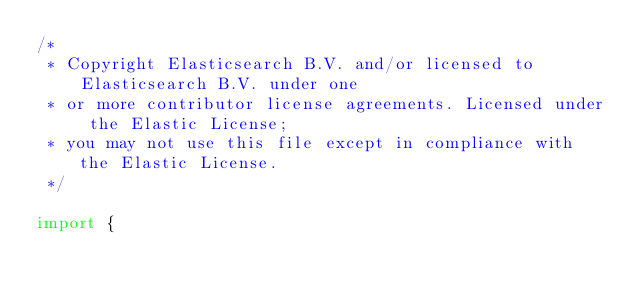<code> <loc_0><loc_0><loc_500><loc_500><_TypeScript_>/*
 * Copyright Elasticsearch B.V. and/or licensed to Elasticsearch B.V. under one
 * or more contributor license agreements. Licensed under the Elastic License;
 * you may not use this file except in compliance with the Elastic License.
 */

import {</code> 